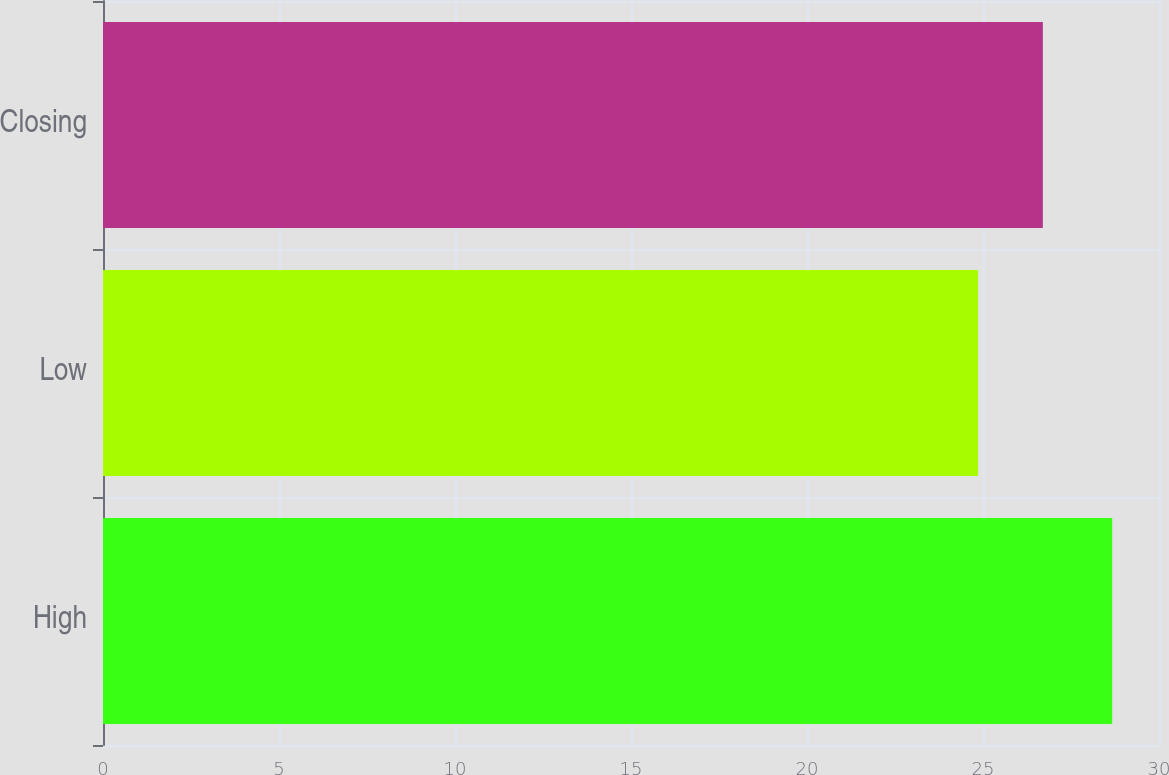<chart> <loc_0><loc_0><loc_500><loc_500><bar_chart><fcel>High<fcel>Low<fcel>Closing<nl><fcel>28.67<fcel>24.86<fcel>26.7<nl></chart> 